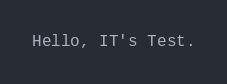Convert code to text. <code><loc_0><loc_0><loc_500><loc_500><_PHP_>Hello, IT's Test.
</code> 